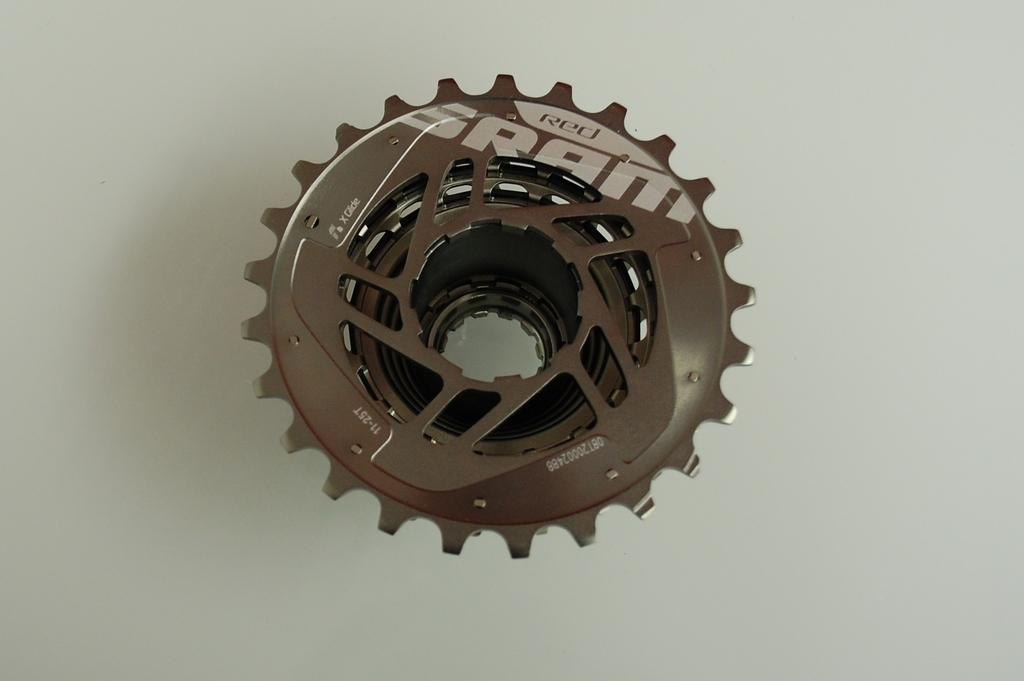What is the main object in the image? There is a gear-like object in the image. What color is the background of the image? The background of the image is white. How many pigs are sitting on the chairs in the image? There are no pigs or chairs present in the image. What type of order is being followed in the image? There is no order or sequence being followed in the image, as it only features a gear-like object on a white background. 